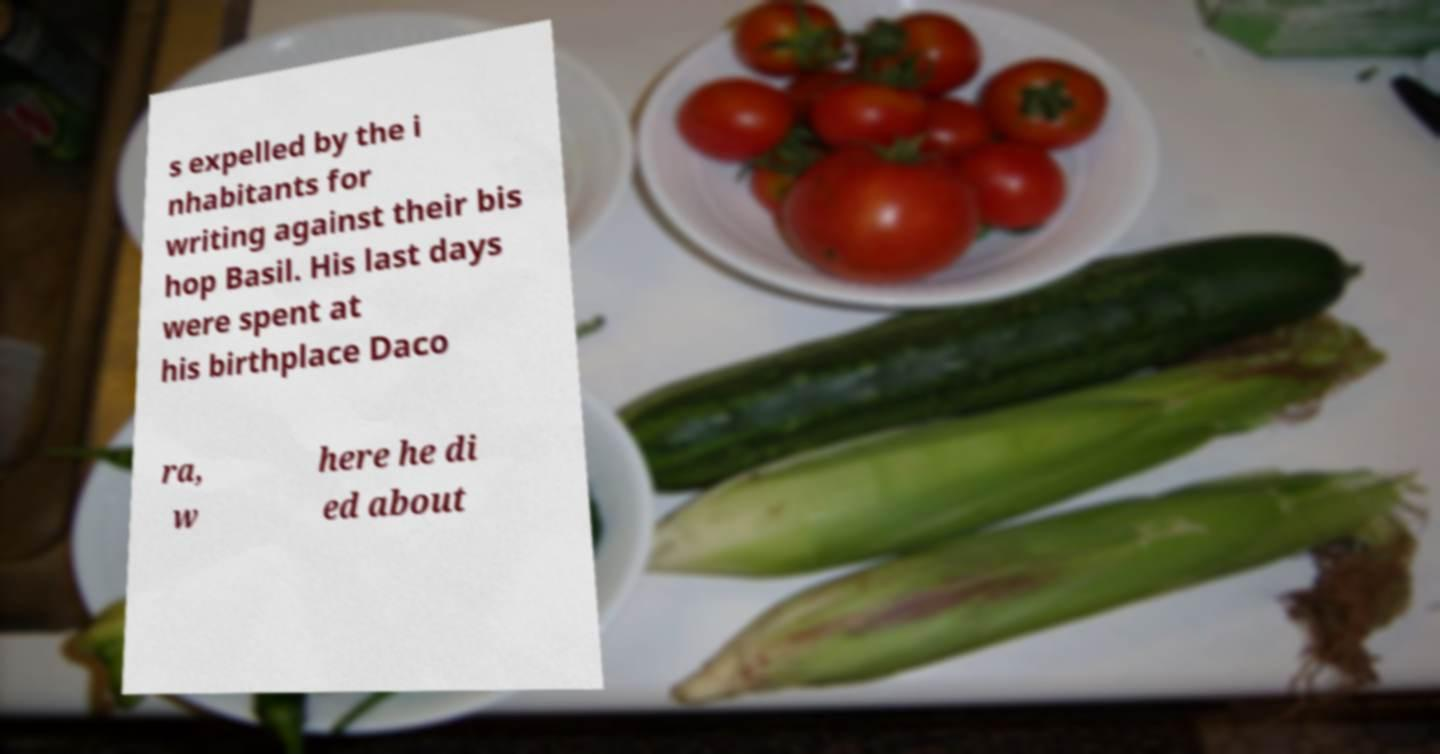Could you extract and type out the text from this image? s expelled by the i nhabitants for writing against their bis hop Basil. His last days were spent at his birthplace Daco ra, w here he di ed about 